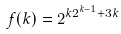Convert formula to latex. <formula><loc_0><loc_0><loc_500><loc_500>f ( k ) = 2 ^ { k 2 ^ { k - 1 } + 3 k }</formula> 